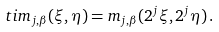Convert formula to latex. <formula><loc_0><loc_0><loc_500><loc_500>\ t i m _ { j , \beta } ( \xi , \eta ) = m _ { j , \beta } ( 2 ^ { j } \xi , 2 ^ { j } \eta ) \, .</formula> 